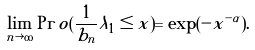<formula> <loc_0><loc_0><loc_500><loc_500>\lim _ { n \rightarrow \infty } \Pr o ( \frac { 1 } { b _ { n } } \lambda _ { 1 } \leq x ) = \exp ( - x ^ { - \alpha } ) .</formula> 